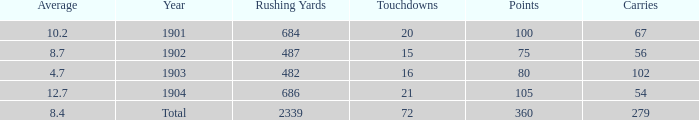What is the average number of carries that have more than 72 touchdowns? None. 